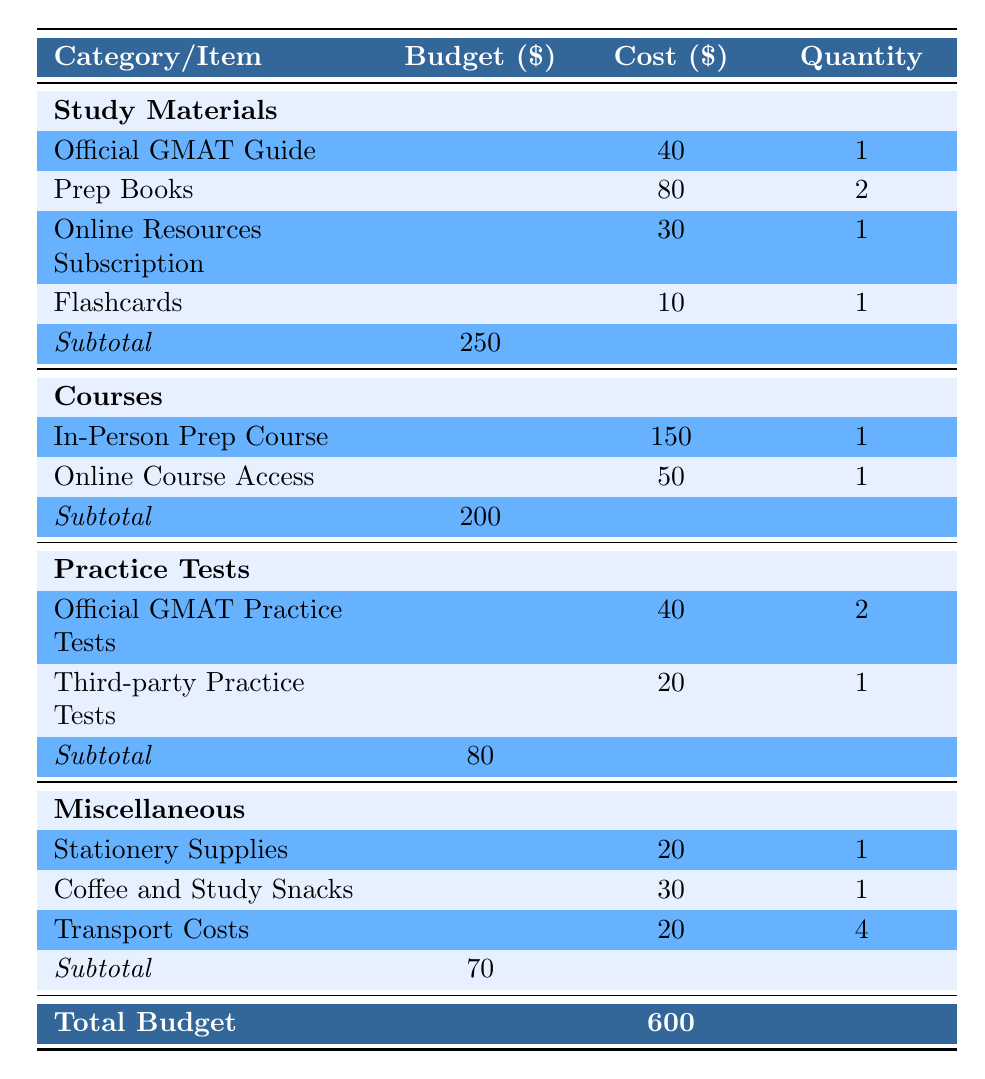What is the total budget for GMAT preparation? The total budget is explicitly listed in the table under the "Total Budget" row, which shows 600.
Answer: 600 What is the budget allocated for Study Materials? The budget for Study Materials can be found under the corresponding segment, which outlines a budget of 250.
Answer: 250 How many Official GMAT Practice Tests can be taken? The quantity for Official GMAT Practice Tests is mentioned as 2 in the Practice Tests section of the table.
Answer: 2 What is the total cost for the Courses category? To compute the total cost for the Courses category, add the cost of the "In-Person Prep Course" (150) and "Online Course Access" (50), which gives 150 + 50 = 200.
Answer: 200 Is the total budget higher than the budget for Miscellaneous? The total budget (600) is indeed higher than the Miscellaneous budget (70) as noted in the table.
Answer: Yes What is the total expenditure on Practice Tests? The expenditure for Practice Tests can be calculated by adding the costs: "Official GMAT Practice Tests" cost (40 x 2 = 80) and "Third-party Practice Tests" cost (20 x 1 = 20). Thus, total cost = 80 + 20 = 100.
Answer: 100 What is the difference in budget between Study Materials and Courses? The difference can be calculated by subtracting the Courses budget (200) from the Study Materials budget (250). Therefore, 250 - 200 = 50.
Answer: 50 How much is spent on Coffee and Study Snacks? The cost for Coffee and Study Snacks is specified as 30 in the Miscellaneous category of the table.
Answer: 30 What is the subtotal for the Miscellaneous category? The subtotal for Miscellaneous is directly stated in the table, which is 70.
Answer: 70 Which category has the highest budget allocation? By comparing all category budgets, Study Materials has the highest allocation of 250, which is more than the other categories.
Answer: Study Materials 